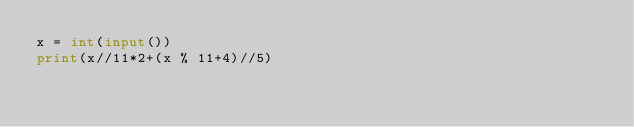Convert code to text. <code><loc_0><loc_0><loc_500><loc_500><_Python_>x = int(input())
print(x//11*2+(x % 11+4)//5)
</code> 